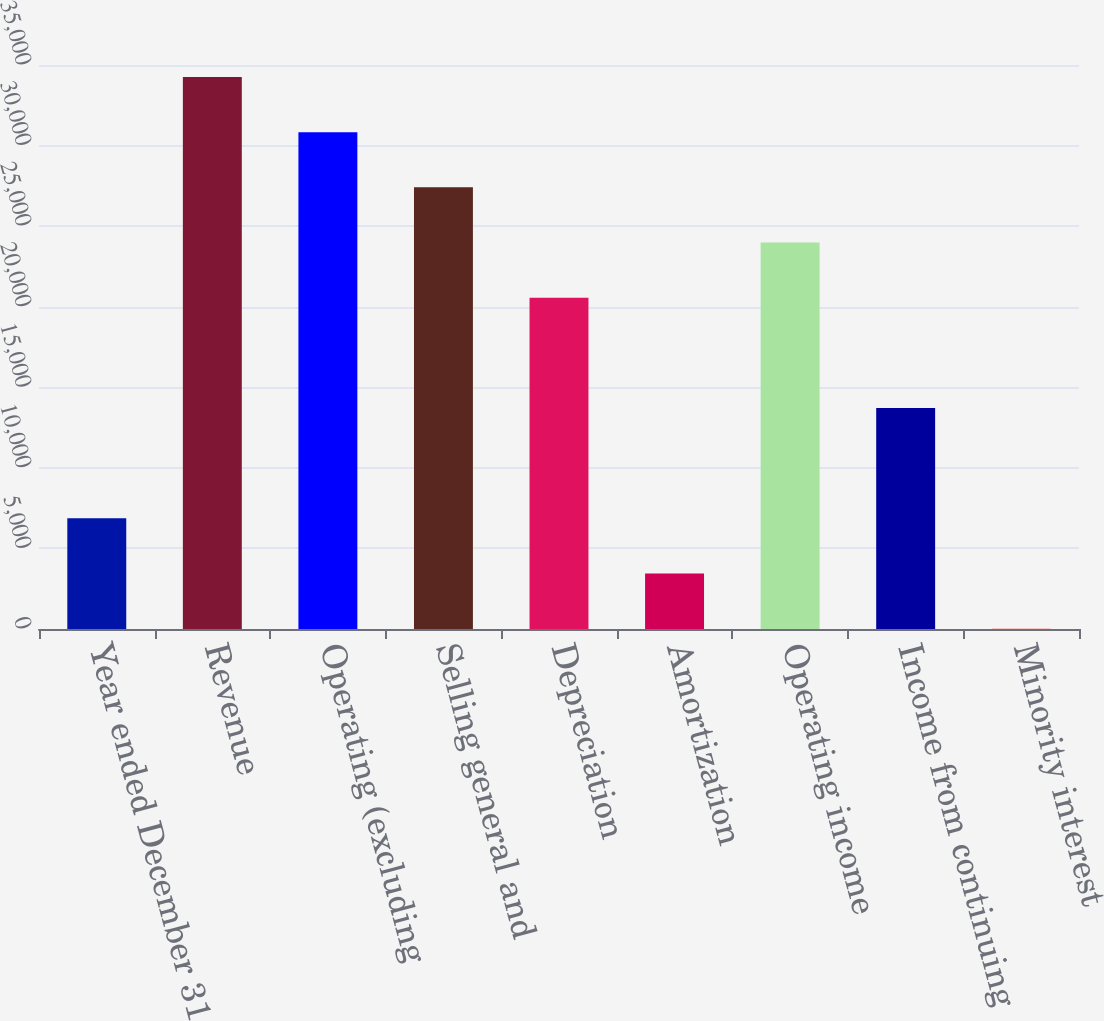Convert chart. <chart><loc_0><loc_0><loc_500><loc_500><bar_chart><fcel>Year ended December 31 (in<fcel>Revenue<fcel>Operating (excluding<fcel>Selling general and<fcel>Depreciation<fcel>Amortization<fcel>Operating income<fcel>Income from continuing<fcel>Minority interest<nl><fcel>6868.8<fcel>34256<fcel>30832.6<fcel>27409.2<fcel>20562.4<fcel>3445.4<fcel>23985.8<fcel>13715.6<fcel>22<nl></chart> 